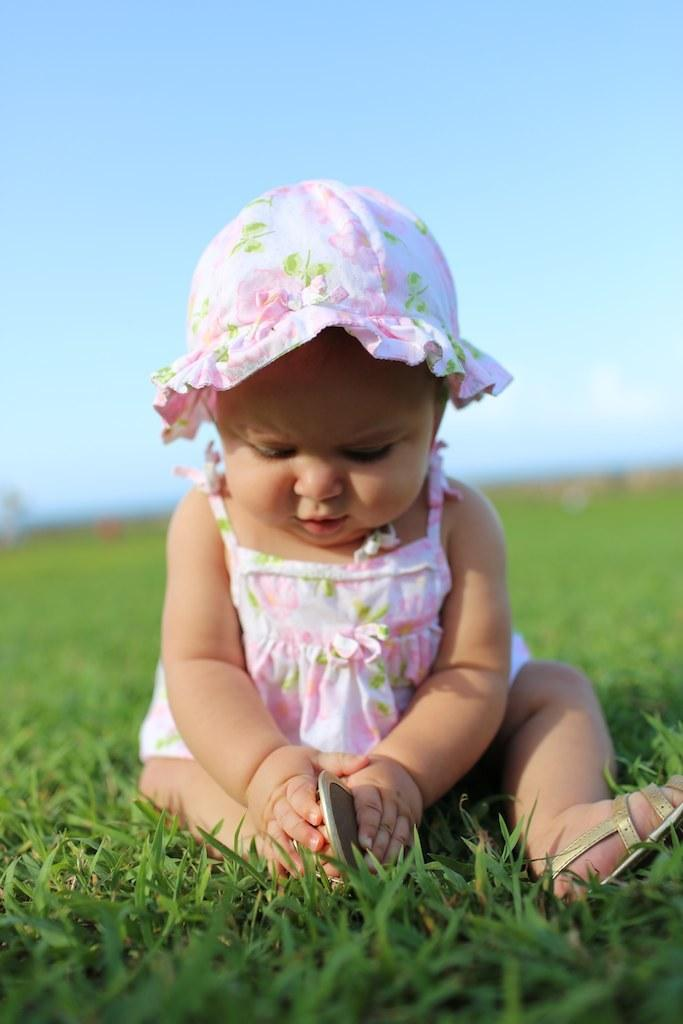What is the main subject of the image? The main subject of the image is a kid. Where is the kid located in the image? The kid is sitting on the grass. What is the kid holding in their hands? The kid is holding an object in their hands. What can be seen in the background of the image? There is a sky visible in the background of the image. What type of chicken is visible in the image? There is no chicken present in the image. What type of wine is the kid drinking in the image? There is no wine present in the image. 